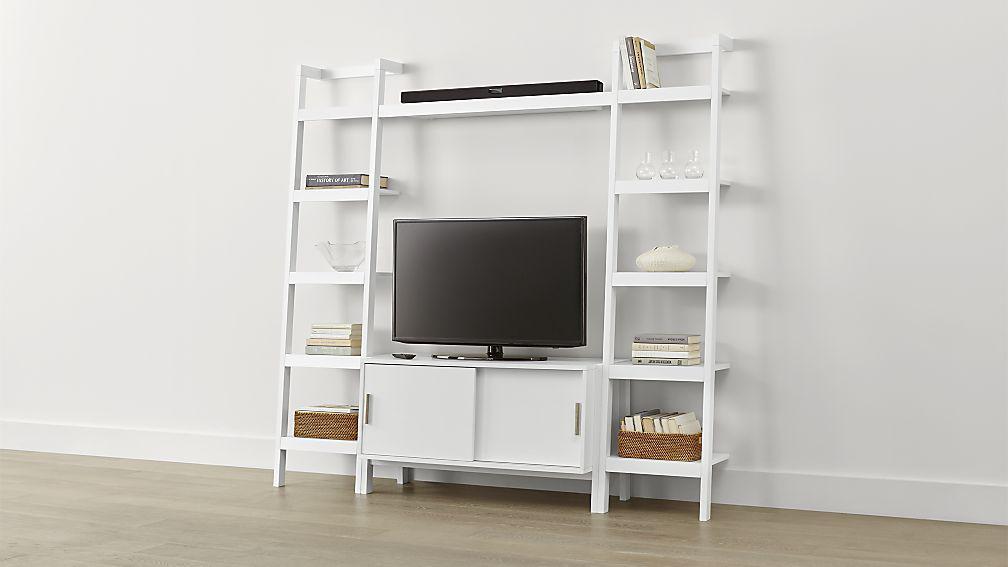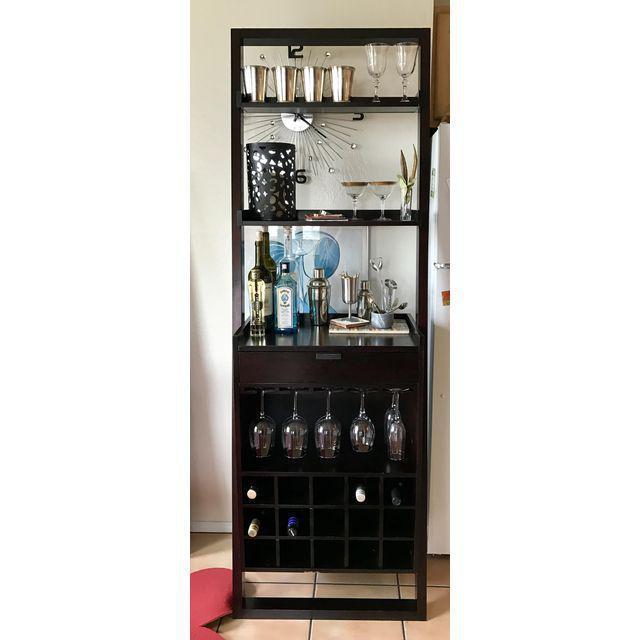The first image is the image on the left, the second image is the image on the right. For the images displayed, is the sentence "The shelf in the image on the left is white, while the shelf on the right is darker." factually correct? Answer yes or no. Yes. The first image is the image on the left, the second image is the image on the right. Assess this claim about the two images: "An image shows a dark storage unit with rows of shelves flanking an X-shaped compartment that holds wine bottles.". Correct or not? Answer yes or no. No. 